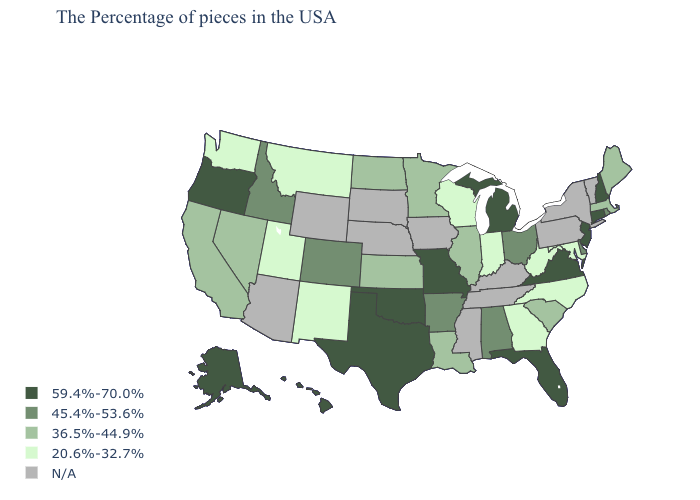What is the value of Tennessee?
Quick response, please. N/A. Among the states that border South Dakota , which have the lowest value?
Give a very brief answer. Montana. What is the value of Florida?
Write a very short answer. 59.4%-70.0%. Is the legend a continuous bar?
Short answer required. No. What is the lowest value in states that border Connecticut?
Answer briefly. 36.5%-44.9%. What is the value of Alaska?
Concise answer only. 59.4%-70.0%. Name the states that have a value in the range 45.4%-53.6%?
Answer briefly. Rhode Island, Delaware, Ohio, Alabama, Arkansas, Colorado, Idaho. Name the states that have a value in the range N/A?
Write a very short answer. Vermont, New York, Pennsylvania, Kentucky, Tennessee, Mississippi, Iowa, Nebraska, South Dakota, Wyoming, Arizona. What is the value of Connecticut?
Quick response, please. 59.4%-70.0%. Does New Jersey have the highest value in the USA?
Short answer required. Yes. Name the states that have a value in the range 59.4%-70.0%?
Short answer required. New Hampshire, Connecticut, New Jersey, Virginia, Florida, Michigan, Missouri, Oklahoma, Texas, Oregon, Alaska, Hawaii. What is the lowest value in states that border Minnesota?
Give a very brief answer. 20.6%-32.7%. Among the states that border Kentucky , does Illinois have the highest value?
Short answer required. No. Name the states that have a value in the range 36.5%-44.9%?
Concise answer only. Maine, Massachusetts, South Carolina, Illinois, Louisiana, Minnesota, Kansas, North Dakota, Nevada, California. 